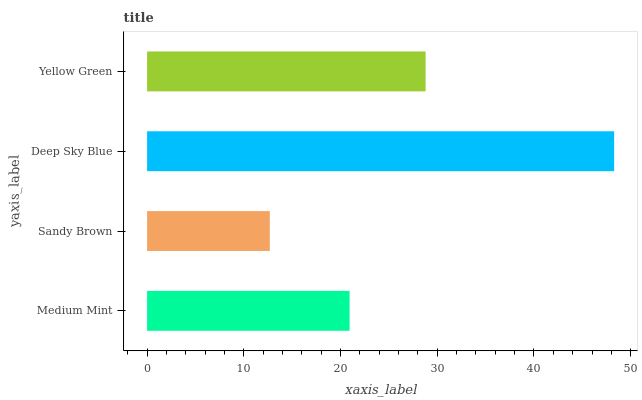Is Sandy Brown the minimum?
Answer yes or no. Yes. Is Deep Sky Blue the maximum?
Answer yes or no. Yes. Is Deep Sky Blue the minimum?
Answer yes or no. No. Is Sandy Brown the maximum?
Answer yes or no. No. Is Deep Sky Blue greater than Sandy Brown?
Answer yes or no. Yes. Is Sandy Brown less than Deep Sky Blue?
Answer yes or no. Yes. Is Sandy Brown greater than Deep Sky Blue?
Answer yes or no. No. Is Deep Sky Blue less than Sandy Brown?
Answer yes or no. No. Is Yellow Green the high median?
Answer yes or no. Yes. Is Medium Mint the low median?
Answer yes or no. Yes. Is Medium Mint the high median?
Answer yes or no. No. Is Deep Sky Blue the low median?
Answer yes or no. No. 